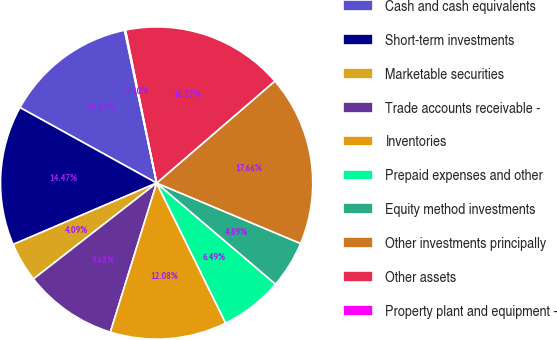<chart> <loc_0><loc_0><loc_500><loc_500><pie_chart><fcel>Cash and cash equivalents<fcel>Short-term investments<fcel>Marketable securities<fcel>Trade accounts receivable -<fcel>Inventories<fcel>Prepaid expenses and other<fcel>Equity method investments<fcel>Other investments principally<fcel>Other assets<fcel>Property plant and equipment -<nl><fcel>13.67%<fcel>14.47%<fcel>4.09%<fcel>9.68%<fcel>12.08%<fcel>6.49%<fcel>4.89%<fcel>17.66%<fcel>16.87%<fcel>0.1%<nl></chart> 